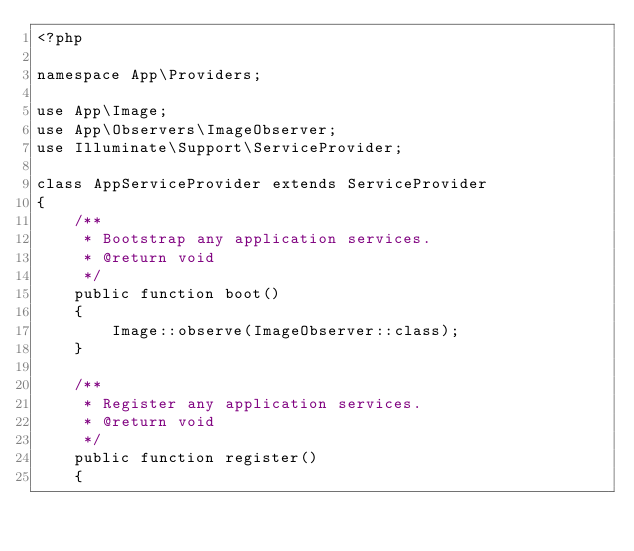<code> <loc_0><loc_0><loc_500><loc_500><_PHP_><?php

namespace App\Providers;

use App\Image;
use App\Observers\ImageObserver;
use Illuminate\Support\ServiceProvider;

class AppServiceProvider extends ServiceProvider
{
    /**
     * Bootstrap any application services.
     * @return void
     */
    public function boot()
    {
        Image::observe(ImageObserver::class);
    }

    /**
     * Register any application services.
     * @return void
     */
    public function register()
    {</code> 